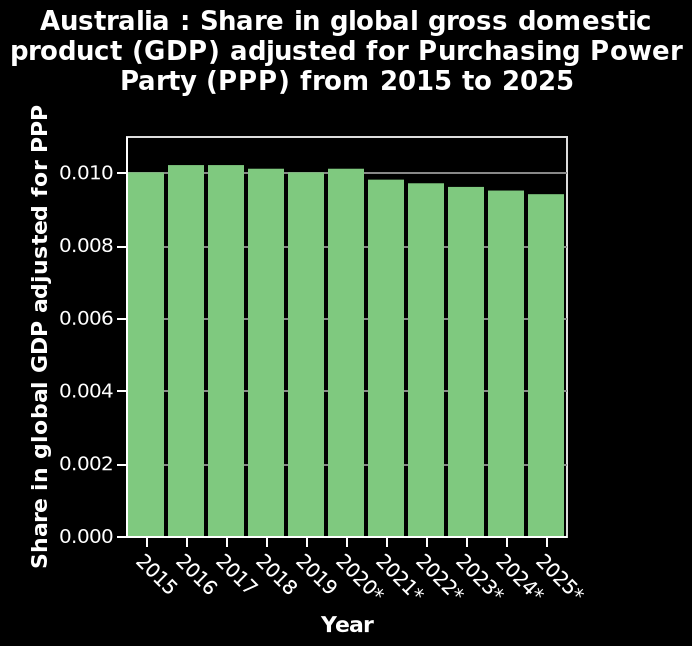<image>
Are the 2015 and 2025 significantly different? No, the 2015 and 2025 have a really small difference. How much time separates the 2015 and 2025?  There is a ten-year gap between the 2015 and 2025. 